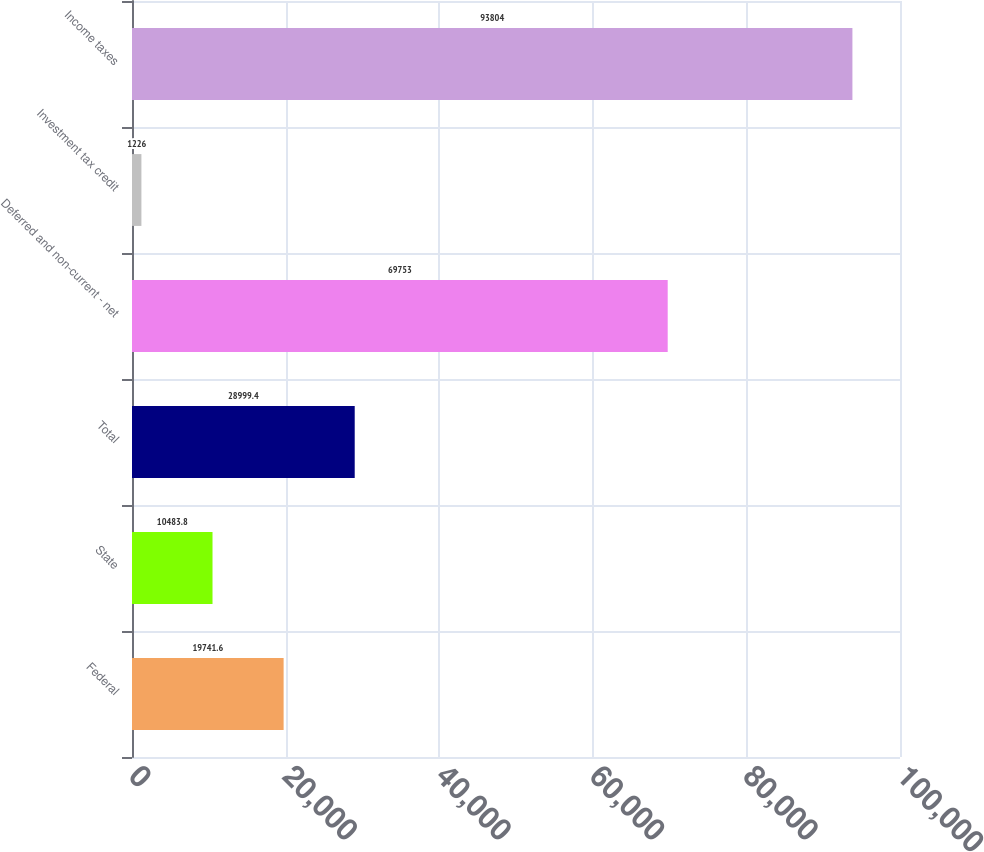Convert chart. <chart><loc_0><loc_0><loc_500><loc_500><bar_chart><fcel>Federal<fcel>State<fcel>Total<fcel>Deferred and non-current - net<fcel>Investment tax credit<fcel>Income taxes<nl><fcel>19741.6<fcel>10483.8<fcel>28999.4<fcel>69753<fcel>1226<fcel>93804<nl></chart> 